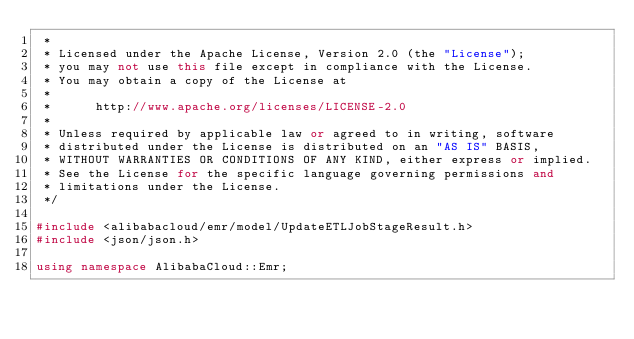Convert code to text. <code><loc_0><loc_0><loc_500><loc_500><_C++_> * 
 * Licensed under the Apache License, Version 2.0 (the "License");
 * you may not use this file except in compliance with the License.
 * You may obtain a copy of the License at
 * 
 *      http://www.apache.org/licenses/LICENSE-2.0
 * 
 * Unless required by applicable law or agreed to in writing, software
 * distributed under the License is distributed on an "AS IS" BASIS,
 * WITHOUT WARRANTIES OR CONDITIONS OF ANY KIND, either express or implied.
 * See the License for the specific language governing permissions and
 * limitations under the License.
 */

#include <alibabacloud/emr/model/UpdateETLJobStageResult.h>
#include <json/json.h>

using namespace AlibabaCloud::Emr;</code> 